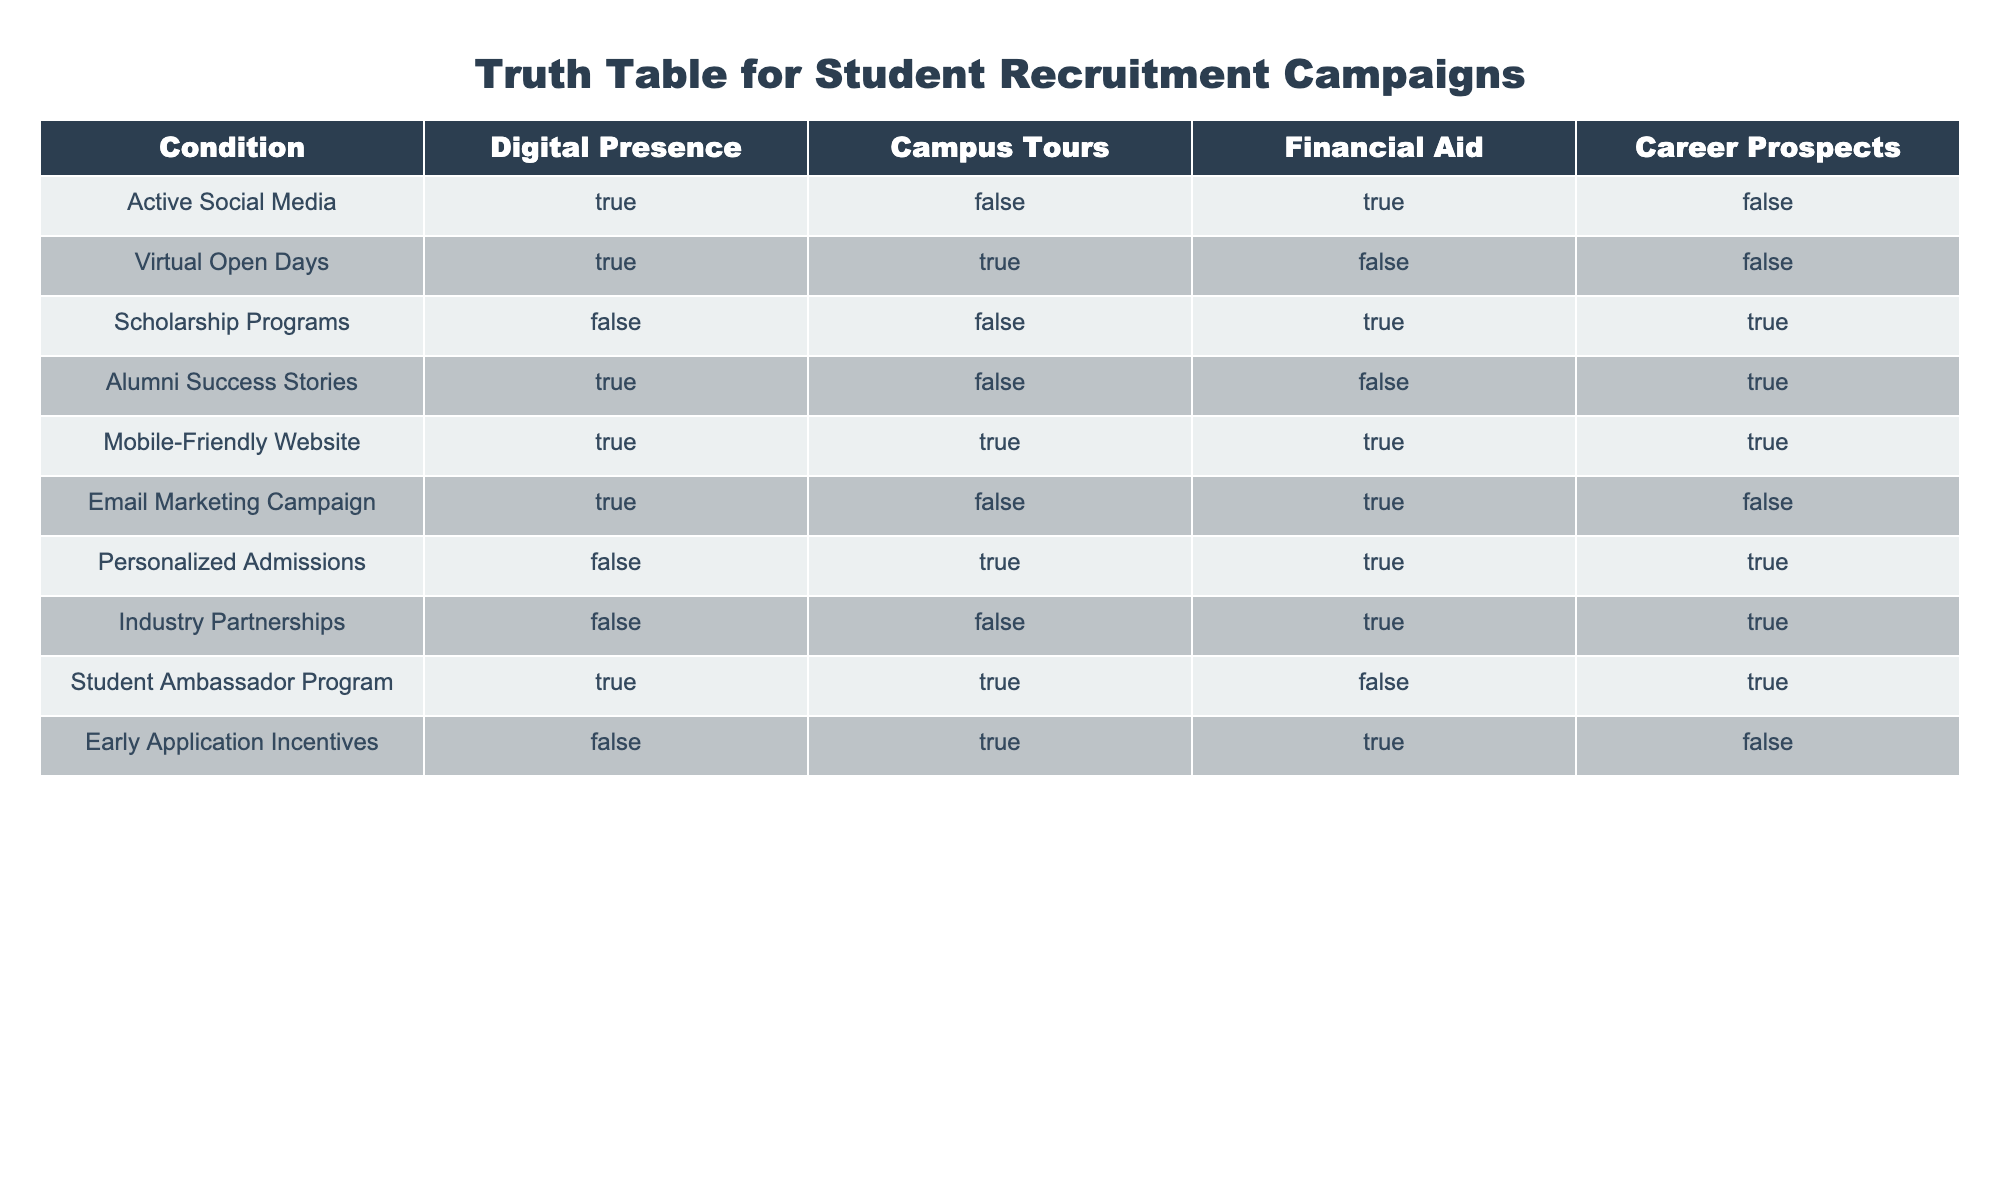What condition has a mobile-friendly website and campus tours but no financial aid? The row that fits this description is "Student Ambassador Program," which has TRUE for both Mobile-Friendly Website and Campus Tours, but FALSE for Financial Aid.
Answer: Student Ambassador Program Which conditions do not offer campus tours? The rows that do not offer campus tours are "Active Social Media," "Scholarship Programs," "Alumni Success Stories," and "Industry Partnerships," as they all have FALSE for Campus Tours.
Answer: Active Social Media, Scholarship Programs, Alumni Success Stories, Industry Partnerships Are there any conditions that provide both financial aid and career prospects? The rows that provide both Financial Aid and Career Prospects are "Scholarship Programs" and "Industry Partnerships," which are TRUE for both conditions.
Answer: Scholarship Programs, Industry Partnerships How many conditions have an active social media presence but lack career prospects? The conditions with an active social media presence (TRUE) are "Active Social Media," "Virtual Open Days," and "Alumni Success Stories." Among these, only "Active Social Media" lacks Career Prospects (FALSE). Counting gives us 1 condition.
Answer: 1 Which condition has the highest combination of TRUE values across all categories? By examining each row, "Mobile-Friendly Website" has TRUE values in all columns (Digital Presence, Campus Tours, Financial Aid, Career Prospects). It is the only condition with a complete set of TRUEs.
Answer: Mobile-Friendly Website Are there any conditions without an active social media presence? The conditions that do not have an active social media presence (FALSE) are "Scholarship Programs," "Personalized Admissions," and "Industry Partnerships." Each of these rows has FALSE for Digital Presence.
Answer: Scholarship Programs, Personalized Admissions, Industry Partnerships What is the relationship between the conditions that have virtual open days and financial aid? The only condition that has Virtual Open Days is "Virtual Open Days," which has FALSE for Financial Aid. Therefore, there’s no condition with Virtual Open Days that also provides Financial Aid.
Answer: None How many conditions have financial aid but do not have digital presence? The rows that have Financial Aid (TRUE) are "Scholarship Programs," "Personalized Admissions," and "Industry Partnerships." Among these, only "Scholarship Programs" and "Industry Partnerships" have FALSE for Digital Presence. So, the count is 2.
Answer: 2 